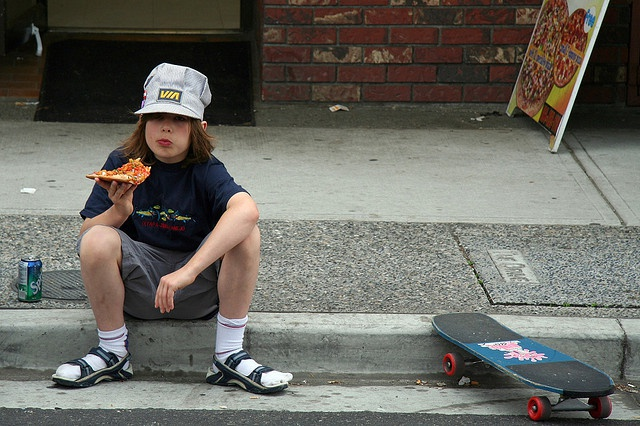Describe the objects in this image and their specific colors. I can see people in black, gray, and lightgray tones, skateboard in black, gray, teal, and blue tones, pizza in black, maroon, brown, and gray tones, and pizza in black, orange, red, brown, and maroon tones in this image. 